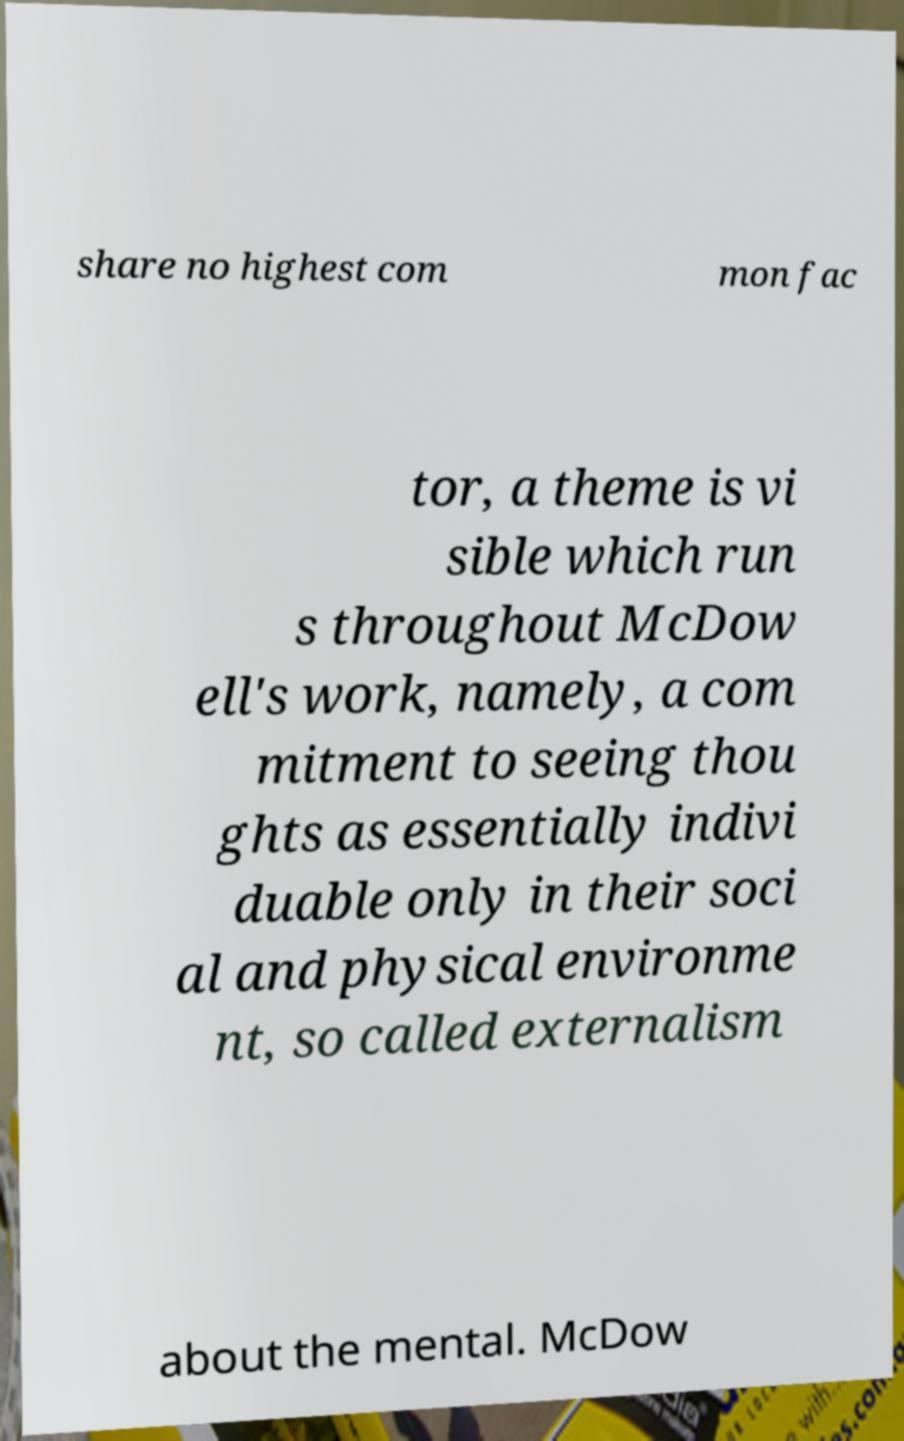Please identify and transcribe the text found in this image. share no highest com mon fac tor, a theme is vi sible which run s throughout McDow ell's work, namely, a com mitment to seeing thou ghts as essentially indivi duable only in their soci al and physical environme nt, so called externalism about the mental. McDow 